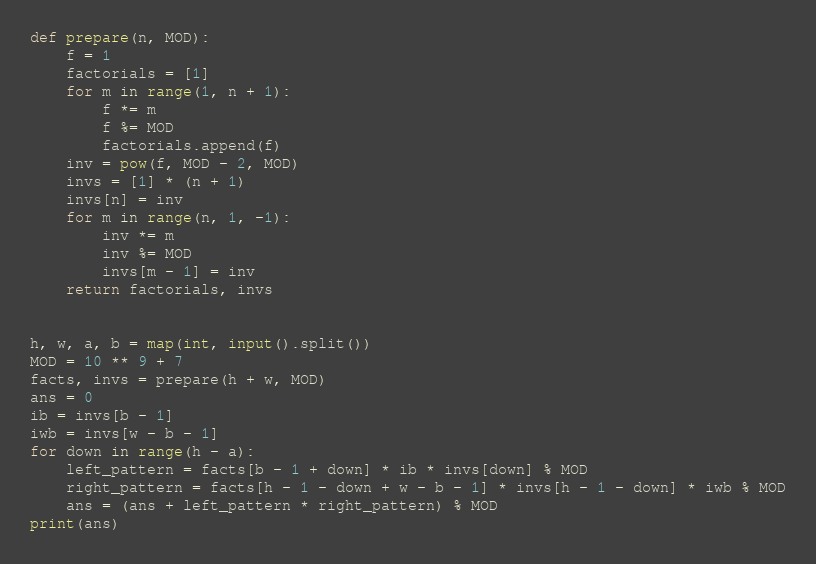Convert code to text. <code><loc_0><loc_0><loc_500><loc_500><_Python_>def prepare(n, MOD):
    f = 1
    factorials = [1]
    for m in range(1, n + 1):
        f *= m
        f %= MOD
        factorials.append(f)
    inv = pow(f, MOD - 2, MOD)
    invs = [1] * (n + 1)
    invs[n] = inv
    for m in range(n, 1, -1):
        inv *= m
        inv %= MOD
        invs[m - 1] = inv
    return factorials, invs


h, w, a, b = map(int, input().split())
MOD = 10 ** 9 + 7
facts, invs = prepare(h + w, MOD)
ans = 0
ib = invs[b - 1]
iwb = invs[w - b - 1]
for down in range(h - a):
    left_pattern = facts[b - 1 + down] * ib * invs[down] % MOD
    right_pattern = facts[h - 1 - down + w - b - 1] * invs[h - 1 - down] * iwb % MOD
    ans = (ans + left_pattern * right_pattern) % MOD
print(ans)
</code> 